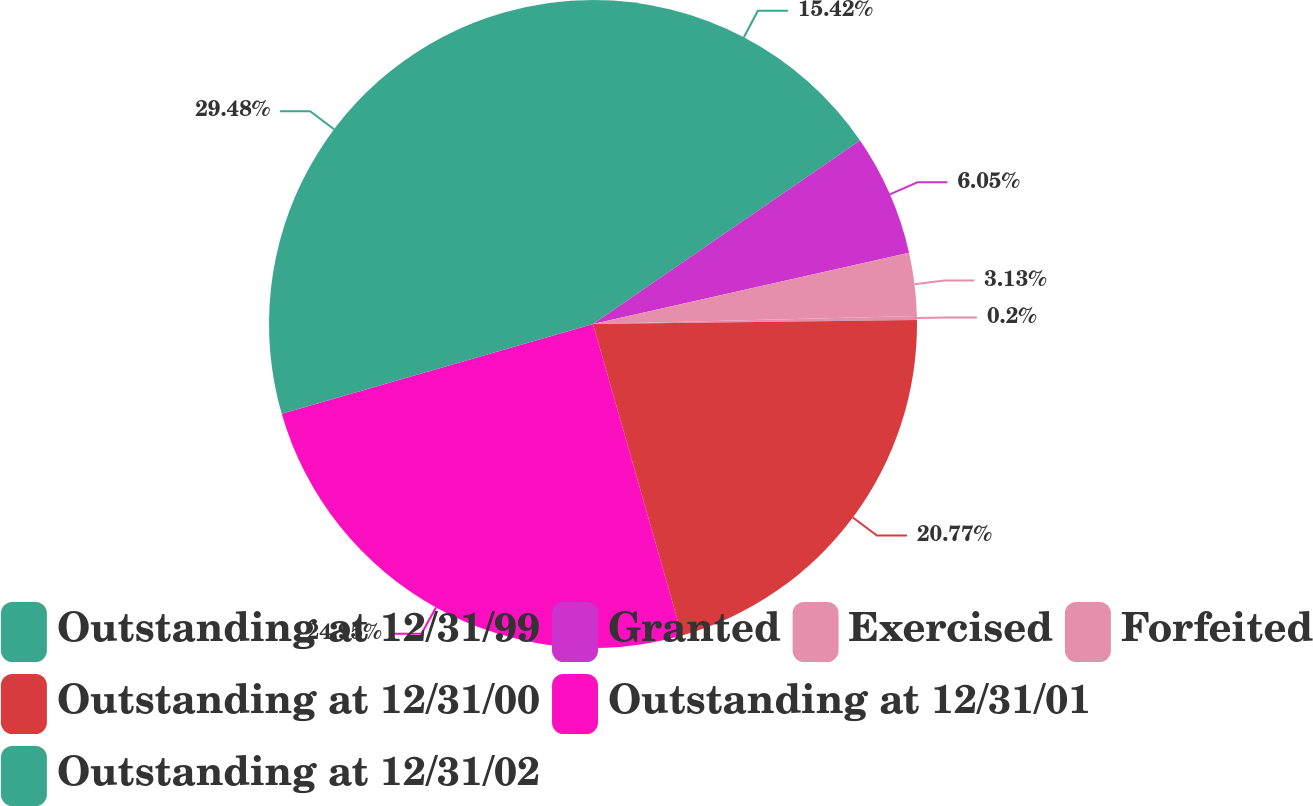<chart> <loc_0><loc_0><loc_500><loc_500><pie_chart><fcel>Outstanding at 12/31/99<fcel>Granted<fcel>Exercised<fcel>Forfeited<fcel>Outstanding at 12/31/00<fcel>Outstanding at 12/31/01<fcel>Outstanding at 12/31/02<nl><fcel>15.42%<fcel>6.05%<fcel>3.13%<fcel>0.2%<fcel>20.77%<fcel>24.95%<fcel>29.47%<nl></chart> 